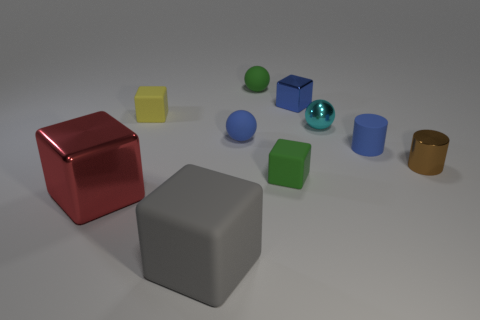Subtract all tiny green balls. How many balls are left? 2 Subtract 1 spheres. How many spheres are left? 2 Subtract all yellow cubes. How many cubes are left? 4 Subtract all spheres. How many objects are left? 7 Subtract all blue balls. Subtract all red cubes. How many balls are left? 2 Subtract 1 blue blocks. How many objects are left? 9 Subtract all big red blocks. Subtract all spheres. How many objects are left? 6 Add 1 blue spheres. How many blue spheres are left? 2 Add 6 small yellow blocks. How many small yellow blocks exist? 7 